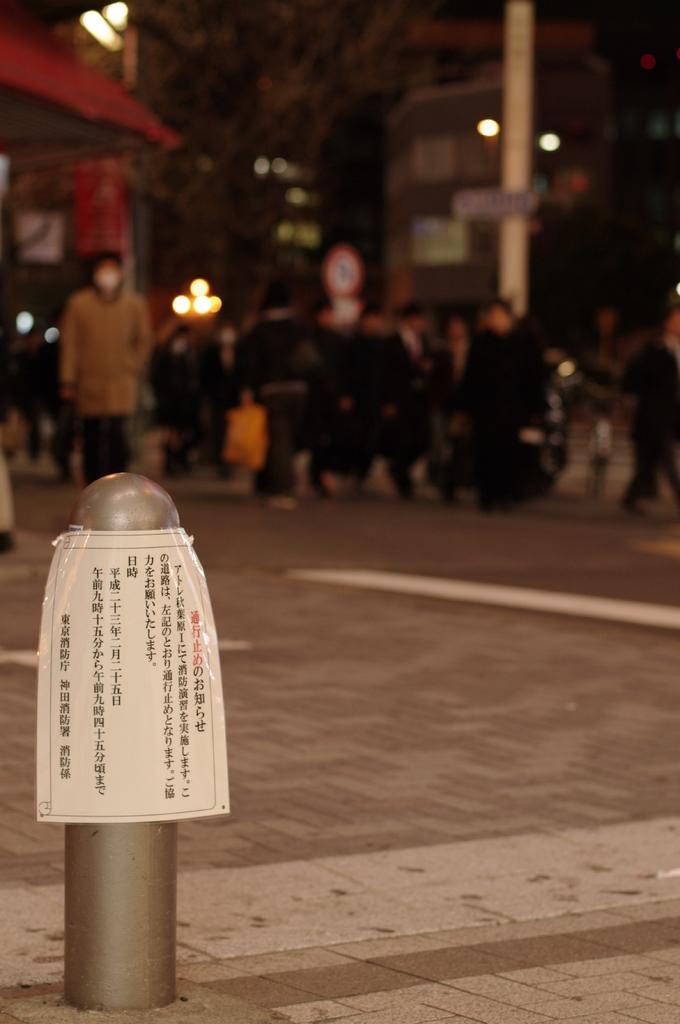What is attached to the pole in the image? There is a notice attached to the pole in the image. What can be observed about the background of the image? The background of the image is blurred. How many people are visible in the image? There are many people in the image. What theory is being proposed by the crack in the notice in the image? There is no crack in the notice in the image, and therefore no theory can be associated with it. 